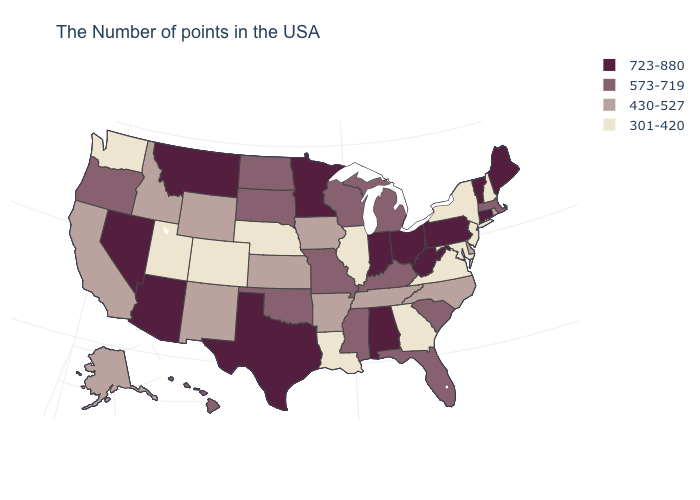Name the states that have a value in the range 430-527?
Answer briefly. Rhode Island, Delaware, North Carolina, Tennessee, Arkansas, Iowa, Kansas, Wyoming, New Mexico, Idaho, California, Alaska. What is the lowest value in the USA?
Be succinct. 301-420. What is the value of Connecticut?
Concise answer only. 723-880. What is the highest value in states that border Minnesota?
Quick response, please. 573-719. Name the states that have a value in the range 430-527?
Quick response, please. Rhode Island, Delaware, North Carolina, Tennessee, Arkansas, Iowa, Kansas, Wyoming, New Mexico, Idaho, California, Alaska. Name the states that have a value in the range 301-420?
Be succinct. New Hampshire, New York, New Jersey, Maryland, Virginia, Georgia, Illinois, Louisiana, Nebraska, Colorado, Utah, Washington. Among the states that border California , which have the highest value?
Write a very short answer. Arizona, Nevada. Does Virginia have a lower value than Illinois?
Be succinct. No. Among the states that border Montana , does North Dakota have the highest value?
Be succinct. Yes. Among the states that border Alabama , which have the highest value?
Quick response, please. Florida, Mississippi. Among the states that border Nevada , which have the lowest value?
Give a very brief answer. Utah. What is the highest value in states that border Utah?
Answer briefly. 723-880. Does the map have missing data?
Concise answer only. No. What is the value of Kansas?
Keep it brief. 430-527. What is the value of Illinois?
Keep it brief. 301-420. 